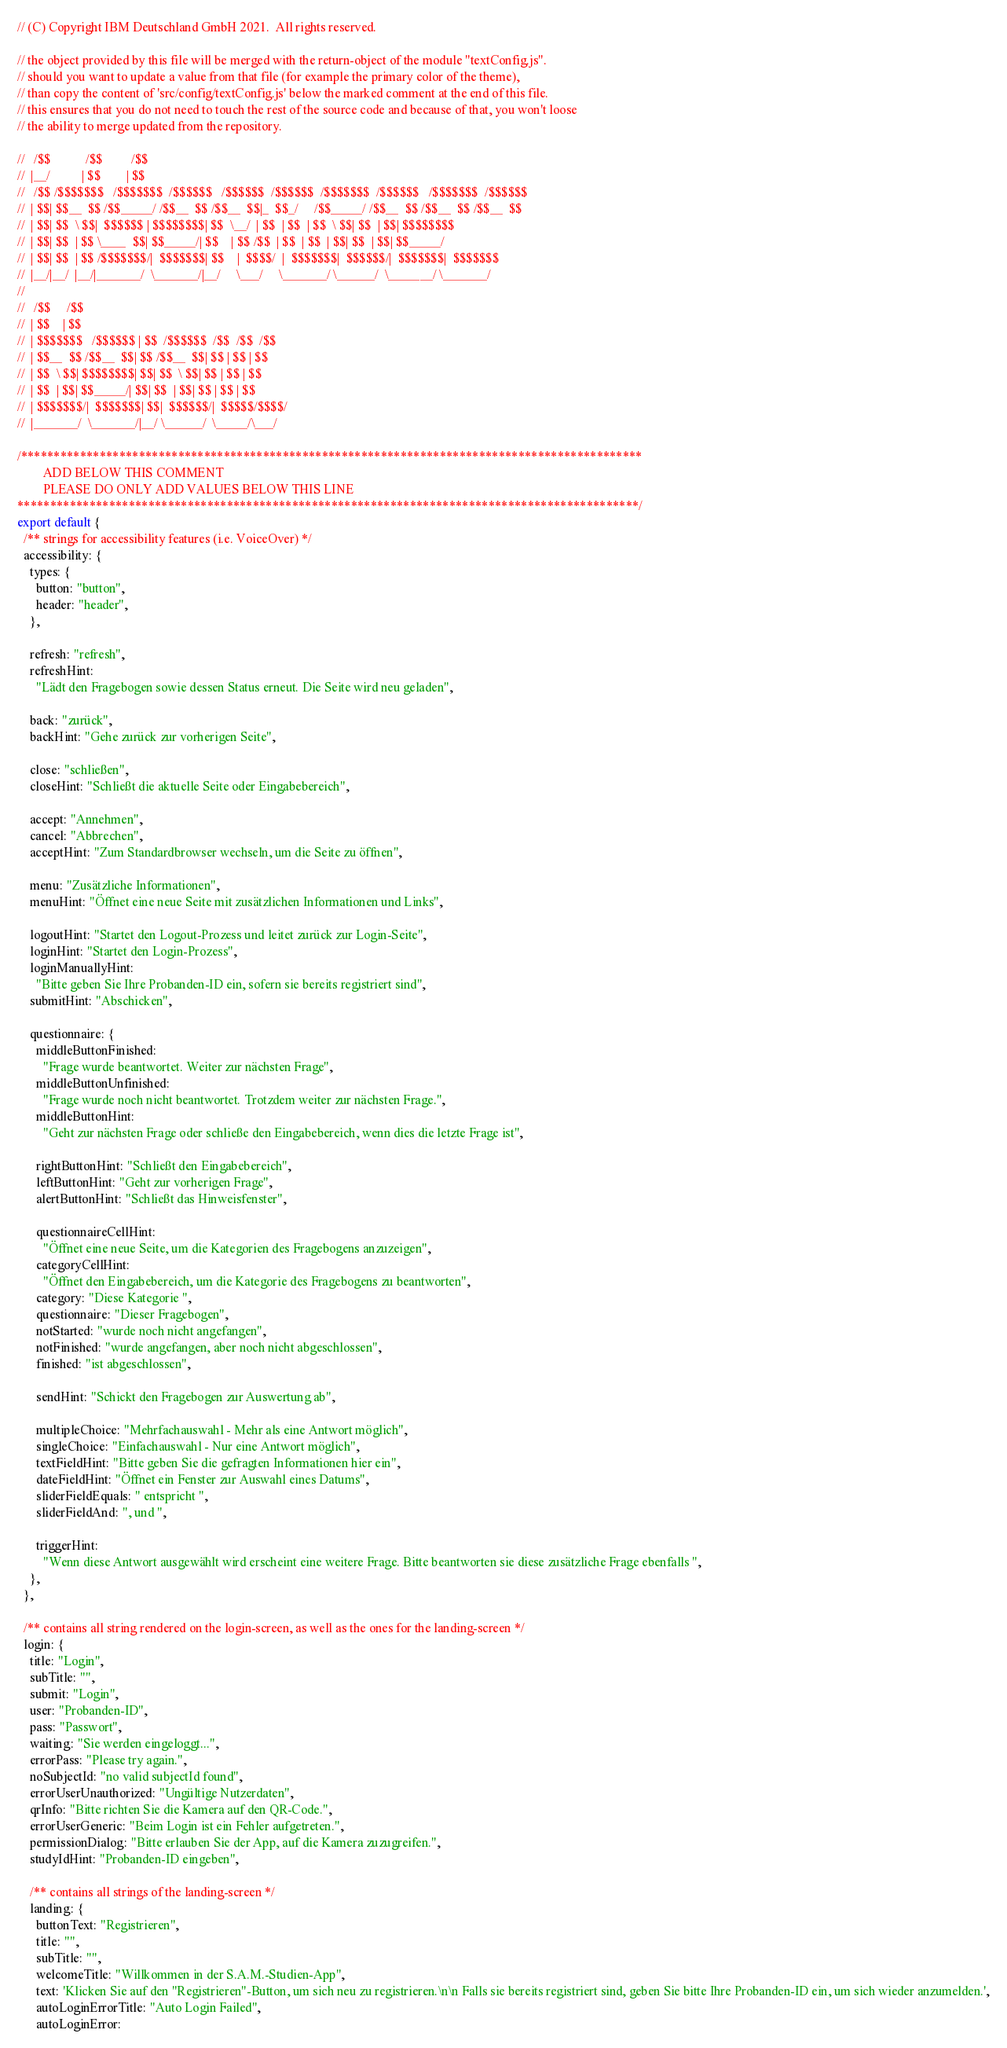<code> <loc_0><loc_0><loc_500><loc_500><_JavaScript_>// (C) Copyright IBM Deutschland GmbH 2021.  All rights reserved.

// the object provided by this file will be merged with the return-object of the module "textConfig.js".
// should you want to update a value from that file (for example the primary color of the theme),
// than copy the content of 'src/config/textConfig.js' below the marked comment at the end of this file.
// this ensures that you do not need to touch the rest of the source code and because of that, you won't loose
// the ability to merge updated from the repository.

//   /$$           /$$         /$$
//  |__/          | $$        | $$
//   /$$ /$$$$$$$   /$$$$$$$  /$$$$$$   /$$$$$$  /$$$$$$  /$$$$$$$  /$$$$$$   /$$$$$$$  /$$$$$$
//  | $$| $$__  $$ /$$_____/ /$$__  $$ /$$__  $$|_  $$_/     /$$_____/ /$$__  $$ /$$__  $$ /$$__  $$
//  | $$| $$  \ $$|  $$$$$$ | $$$$$$$$| $$  \__/  | $$  | $$  | $$  \ $$| $$  | $$| $$$$$$$$
//  | $$| $$  | $$ \____  $$| $$_____/| $$    | $$ /$$  | $$  | $$  | $$| $$  | $$| $$_____/
//  | $$| $$  | $$ /$$$$$$$/|  $$$$$$$| $$    |  $$$$/  |  $$$$$$$|  $$$$$$/|  $$$$$$$|  $$$$$$$
//  |__/|__/  |__/|_______/  \_______/|__/     \___/     \_______/ \______/  \_______/ \_______/
//
//   /$$     /$$
//  | $$    | $$
//  | $$$$$$$   /$$$$$$ | $$  /$$$$$$  /$$  /$$  /$$
//  | $$__  $$ /$$__  $$| $$ /$$__  $$| $$ | $$ | $$
//  | $$  \ $$| $$$$$$$$| $$| $$  \ $$| $$ | $$ | $$
//  | $$  | $$| $$_____/| $$| $$  | $$| $$ | $$ | $$
//  | $$$$$$$/|  $$$$$$$| $$|  $$$$$$/|  $$$$$/$$$$/
//  |_______/  \_______/|__/ \______/  \_____/\___/

/***********************************************************************************************
        ADD BELOW THIS COMMENT
        PLEASE DO ONLY ADD VALUES BELOW THIS LINE
***********************************************************************************************/
export default {
  /** strings for accessibility features (i.e. VoiceOver) */
  accessibility: {
    types: {
      button: "button",
      header: "header",
    },

    refresh: "refresh",
    refreshHint:
      "Lädt den Fragebogen sowie dessen Status erneut. Die Seite wird neu geladen",

    back: "zurück",
    backHint: "Gehe zurück zur vorherigen Seite",

    close: "schließen",
    closeHint: "Schließt die aktuelle Seite oder Eingabebereich",

    accept: "Annehmen",
    cancel: "Abbrechen",
    acceptHint: "Zum Standardbrowser wechseln, um die Seite zu öffnen",

    menu: "Zusätzliche Informationen",
    menuHint: "Öffnet eine neue Seite mit zusätzlichen Informationen und Links",

    logoutHint: "Startet den Logout-Prozess und leitet zurück zur Login-Seite",
    loginHint: "Startet den Login-Prozess",
    loginManuallyHint:
      "Bitte geben Sie Ihre Probanden-ID ein, sofern sie bereits registriert sind",
    submitHint: "Abschicken",

    questionnaire: {
      middleButtonFinished:
        "Frage wurde beantwortet. Weiter zur nächsten Frage",
      middleButtonUnfinished:
        "Frage wurde noch nicht beantwortet. Trotzdem weiter zur nächsten Frage.",
      middleButtonHint:
        "Geht zur nächsten Frage oder schließe den Eingabebereich, wenn dies die letzte Frage ist",

      rightButtonHint: "Schließt den Eingabebereich",
      leftButtonHint: "Geht zur vorherigen Frage",
      alertButtonHint: "Schließt das Hinweisfenster",

      questionnaireCellHint:
        "Öffnet eine neue Seite, um die Kategorien des Fragebogens anzuzeigen",
      categoryCellHint:
        "Öffnet den Eingabebereich, um die Kategorie des Fragebogens zu beantworten",
      category: "Diese Kategorie ",
      questionnaire: "Dieser Fragebogen",
      notStarted: "wurde noch nicht angefangen",
      notFinished: "wurde angefangen, aber noch nicht abgeschlossen",
      finished: "ist abgeschlossen",

      sendHint: "Schickt den Fragebogen zur Auswertung ab",

      multipleChoice: "Mehrfachauswahl - Mehr als eine Antwort möglich",
      singleChoice: "Einfachauswahl - Nur eine Antwort möglich",
      textFieldHint: "Bitte geben Sie die gefragten Informationen hier ein",
      dateFieldHint: "Öffnet ein Fenster zur Auswahl eines Datums",
      sliderFieldEquals: " entspricht ",
      sliderFieldAnd: ", und ",

      triggerHint:
        "Wenn diese Antwort ausgewählt wird erscheint eine weitere Frage. Bitte beantworten sie diese zusätzliche Frage ebenfalls ",
    },
  },

  /** contains all string rendered on the login-screen, as well as the ones for the landing-screen */
  login: {
    title: "Login",
    subTitle: "",
    submit: "Login",
    user: "Probanden-ID",
    pass: "Passwort",
    waiting: "Sie werden eingeloggt...",
    errorPass: "Please try again.",
    noSubjectId: "no valid subjectId found",
    errorUserUnauthorized: "Ungültige Nutzerdaten",
    qrInfo: "Bitte richten Sie die Kamera auf den QR-Code.",
    errorUserGeneric: "Beim Login ist ein Fehler aufgetreten.",
    permissionDialog: "Bitte erlauben Sie der App, auf die Kamera zuzugreifen.",
    studyIdHint: "Probanden-ID eingeben",

    /** contains all strings of the landing-screen */
    landing: {
      buttonText: "Registrieren",
      title: "",
      subTitle: "",
      welcomeTitle: "Willkommen in der S.A.M.-Studien-App",
      text: 'Klicken Sie auf den "Registrieren"-Button, um sich neu zu registrieren.\n\n Falls sie bereits registriert sind, geben Sie bitte Ihre Probanden-ID ein, um sich wieder anzumelden.',
      autoLoginErrorTitle: "Auto Login Failed",
      autoLoginError:</code> 